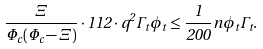<formula> <loc_0><loc_0><loc_500><loc_500>\frac { \Xi } { \Phi _ { c } ( \Phi _ { c } - \Xi ) } \cdot 1 1 2 \cdot q ^ { 2 } \Gamma _ { t } \phi _ { t } \leq \frac { 1 } { 2 0 0 } n \phi _ { t } \Gamma _ { t } .</formula> 